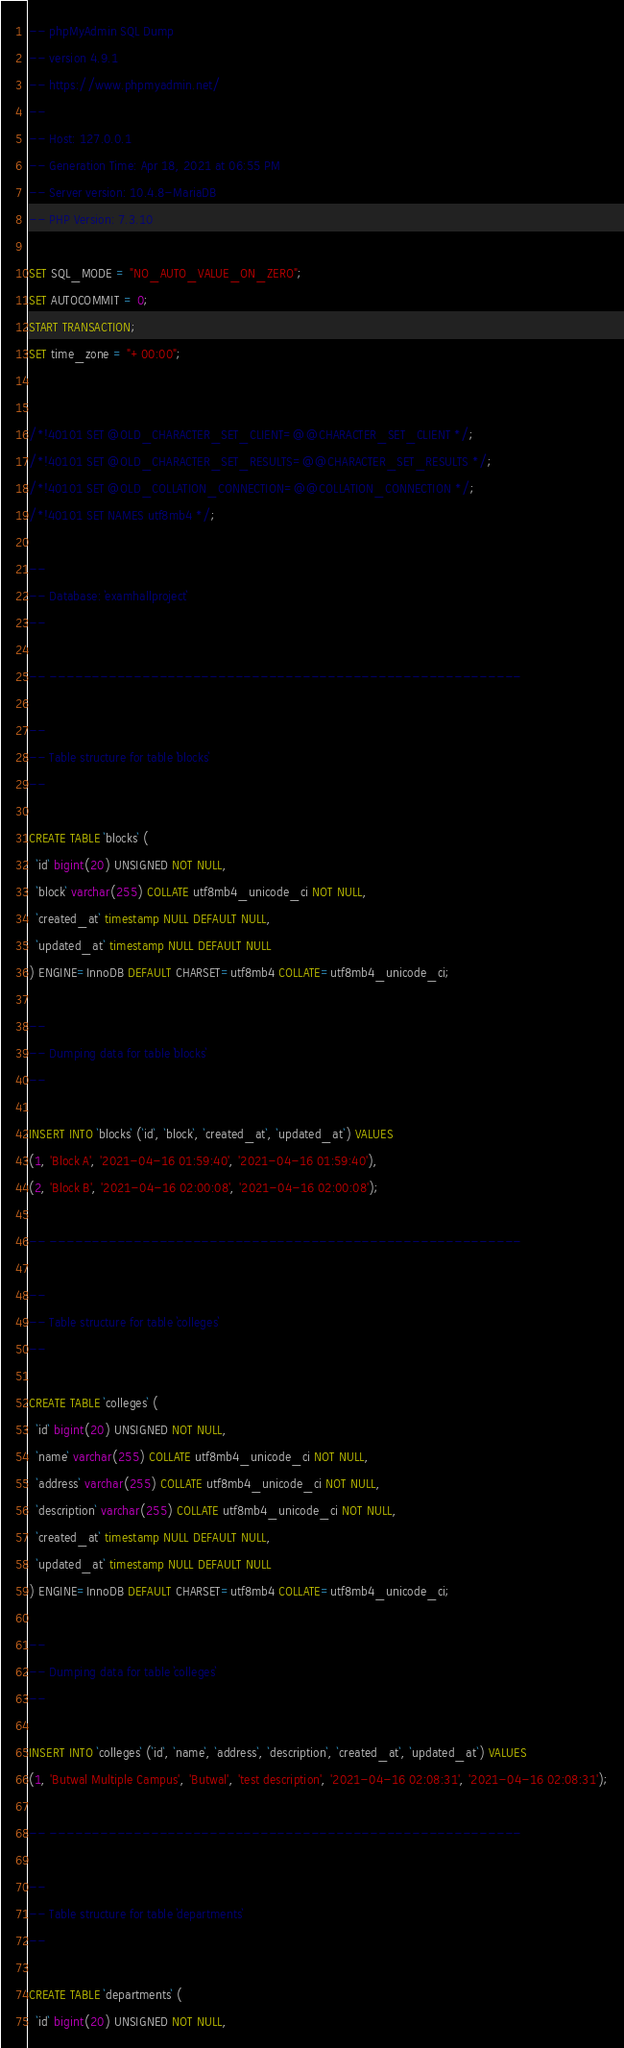Convert code to text. <code><loc_0><loc_0><loc_500><loc_500><_SQL_>-- phpMyAdmin SQL Dump
-- version 4.9.1
-- https://www.phpmyadmin.net/
--
-- Host: 127.0.0.1
-- Generation Time: Apr 18, 2021 at 06:55 PM
-- Server version: 10.4.8-MariaDB
-- PHP Version: 7.3.10

SET SQL_MODE = "NO_AUTO_VALUE_ON_ZERO";
SET AUTOCOMMIT = 0;
START TRANSACTION;
SET time_zone = "+00:00";


/*!40101 SET @OLD_CHARACTER_SET_CLIENT=@@CHARACTER_SET_CLIENT */;
/*!40101 SET @OLD_CHARACTER_SET_RESULTS=@@CHARACTER_SET_RESULTS */;
/*!40101 SET @OLD_COLLATION_CONNECTION=@@COLLATION_CONNECTION */;
/*!40101 SET NAMES utf8mb4 */;

--
-- Database: `examhallproject`
--

-- --------------------------------------------------------

--
-- Table structure for table `blocks`
--

CREATE TABLE `blocks` (
  `id` bigint(20) UNSIGNED NOT NULL,
  `block` varchar(255) COLLATE utf8mb4_unicode_ci NOT NULL,
  `created_at` timestamp NULL DEFAULT NULL,
  `updated_at` timestamp NULL DEFAULT NULL
) ENGINE=InnoDB DEFAULT CHARSET=utf8mb4 COLLATE=utf8mb4_unicode_ci;

--
-- Dumping data for table `blocks`
--

INSERT INTO `blocks` (`id`, `block`, `created_at`, `updated_at`) VALUES
(1, 'Block A', '2021-04-16 01:59:40', '2021-04-16 01:59:40'),
(2, 'Block B', '2021-04-16 02:00:08', '2021-04-16 02:00:08');

-- --------------------------------------------------------

--
-- Table structure for table `colleges`
--

CREATE TABLE `colleges` (
  `id` bigint(20) UNSIGNED NOT NULL,
  `name` varchar(255) COLLATE utf8mb4_unicode_ci NOT NULL,
  `address` varchar(255) COLLATE utf8mb4_unicode_ci NOT NULL,
  `description` varchar(255) COLLATE utf8mb4_unicode_ci NOT NULL,
  `created_at` timestamp NULL DEFAULT NULL,
  `updated_at` timestamp NULL DEFAULT NULL
) ENGINE=InnoDB DEFAULT CHARSET=utf8mb4 COLLATE=utf8mb4_unicode_ci;

--
-- Dumping data for table `colleges`
--

INSERT INTO `colleges` (`id`, `name`, `address`, `description`, `created_at`, `updated_at`) VALUES
(1, 'Butwal Multiple Campus', 'Butwal', 'test description', '2021-04-16 02:08:31', '2021-04-16 02:08:31');

-- --------------------------------------------------------

--
-- Table structure for table `departments`
--

CREATE TABLE `departments` (
  `id` bigint(20) UNSIGNED NOT NULL,</code> 